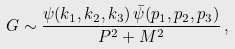<formula> <loc_0><loc_0><loc_500><loc_500>G \sim \frac { \psi ( k _ { 1 } , k _ { 2 } , k _ { 3 } ) \, \bar { \psi } ( p _ { 1 } , p _ { 2 } , p _ { 3 } ) } { P ^ { 2 } + M ^ { 2 } } \, ,</formula> 